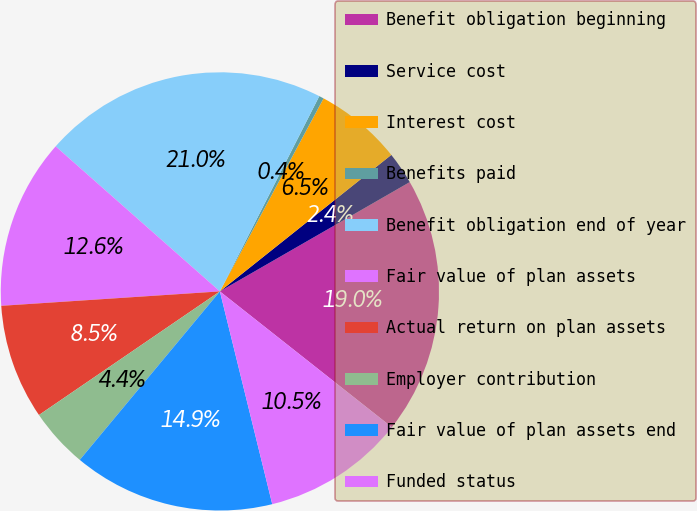<chart> <loc_0><loc_0><loc_500><loc_500><pie_chart><fcel>Benefit obligation beginning<fcel>Service cost<fcel>Interest cost<fcel>Benefits paid<fcel>Benefit obligation end of year<fcel>Fair value of plan assets<fcel>Actual return on plan assets<fcel>Employer contribution<fcel>Fair value of plan assets end<fcel>Funded status<nl><fcel>18.95%<fcel>2.39%<fcel>6.45%<fcel>0.35%<fcel>20.98%<fcel>12.56%<fcel>8.49%<fcel>4.42%<fcel>14.88%<fcel>10.52%<nl></chart> 